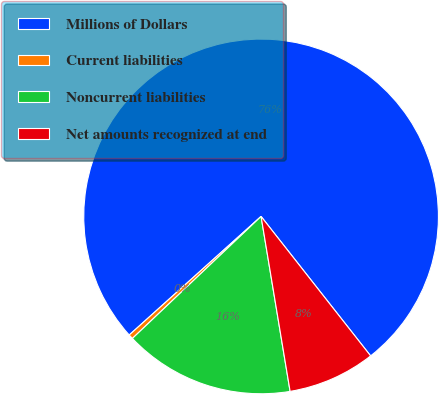Convert chart. <chart><loc_0><loc_0><loc_500><loc_500><pie_chart><fcel>Millions of Dollars<fcel>Current liabilities<fcel>Noncurrent liabilities<fcel>Net amounts recognized at end<nl><fcel>76.06%<fcel>0.42%<fcel>15.54%<fcel>7.98%<nl></chart> 